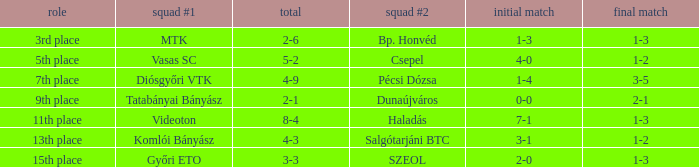What position has a 2-6 agg.? 3rd place. 